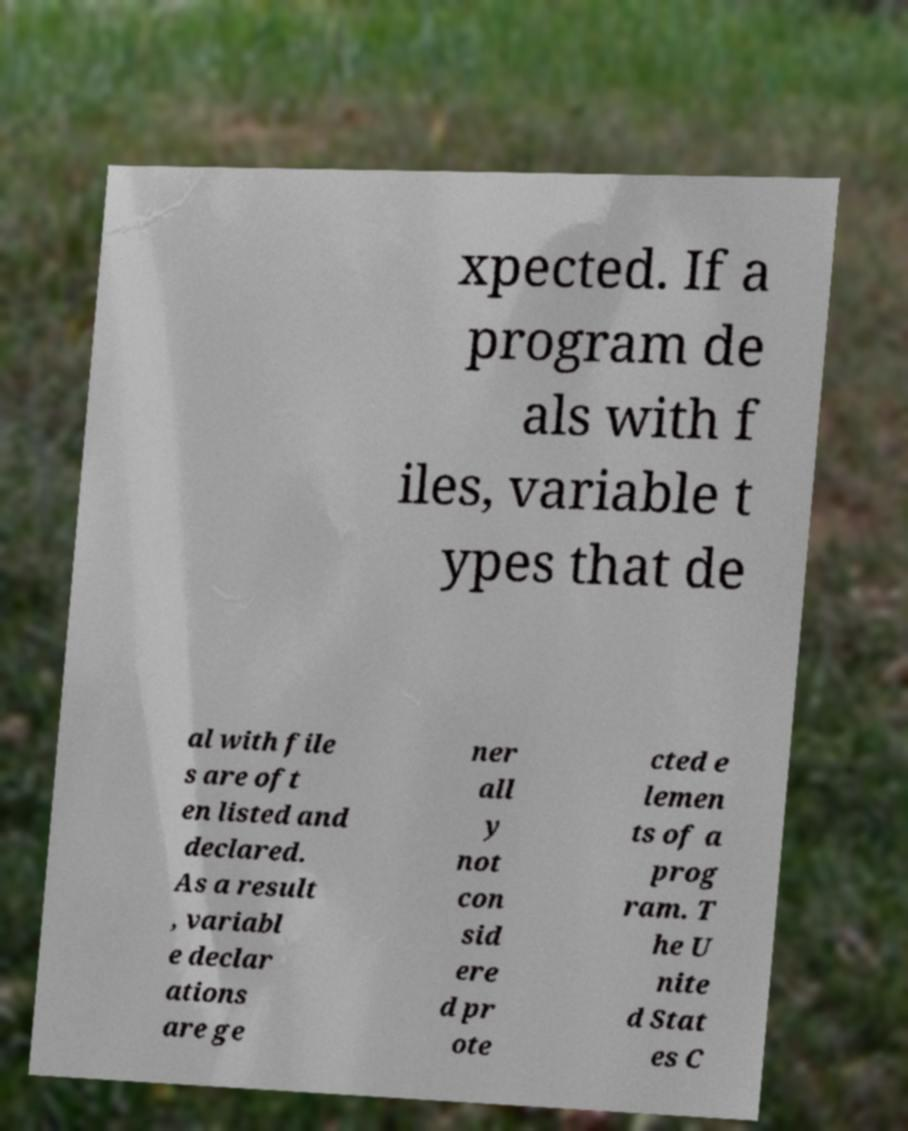Please identify and transcribe the text found in this image. xpected. If a program de als with f iles, variable t ypes that de al with file s are oft en listed and declared. As a result , variabl e declar ations are ge ner all y not con sid ere d pr ote cted e lemen ts of a prog ram. T he U nite d Stat es C 